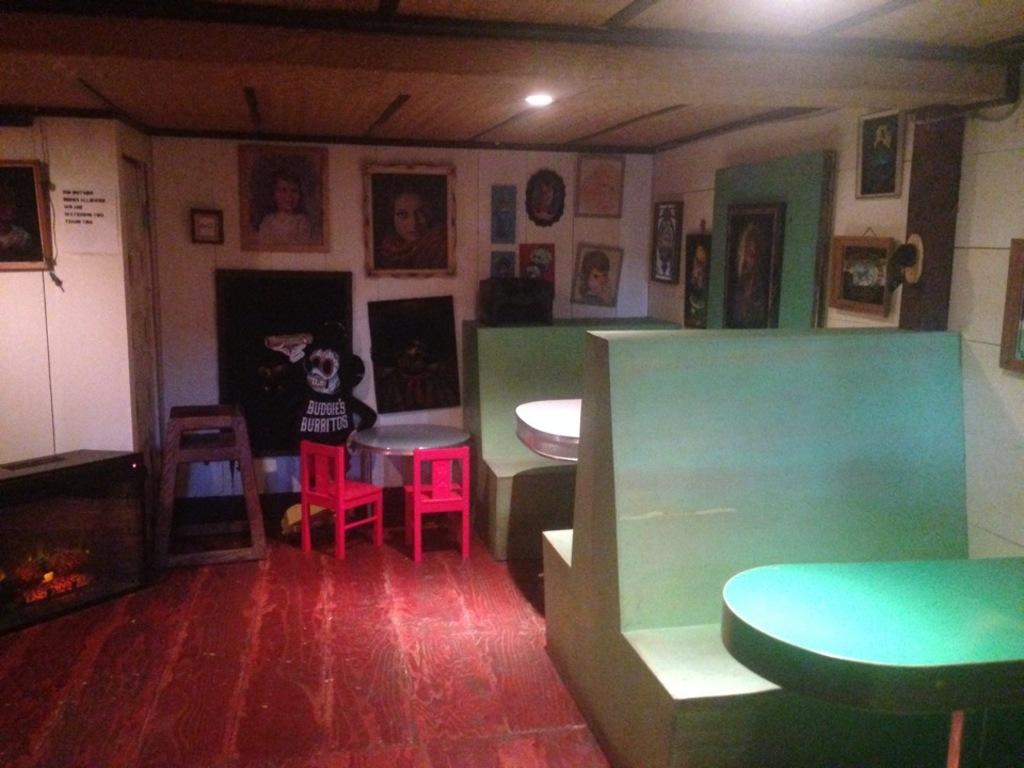What type of furniture is present in the image? There are chairs and tables in the image. What can be used for illumination in the image? There is a light in the image. What decorative elements are on the walls in the image? There are frames on the walls in the image. What type of produce is being harvested in the image? There is no produce or harvesting activity present in the image. What gardening tool is being used in the image? There is no gardening tool or activity present in the image. 